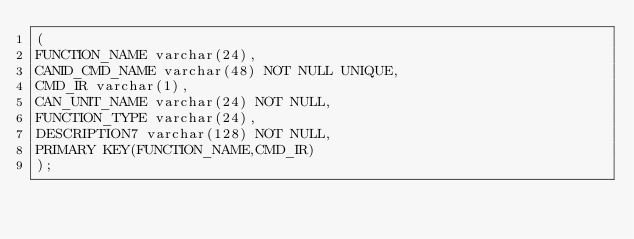Convert code to text. <code><loc_0><loc_0><loc_500><loc_500><_SQL_>(
FUNCTION_NAME varchar(24),
CANID_CMD_NAME varchar(48) NOT NULL UNIQUE,
CMD_IR varchar(1),
CAN_UNIT_NAME varchar(24) NOT NULL,
FUNCTION_TYPE varchar(24),
DESCRIPTION7 varchar(128) NOT NULL,
PRIMARY KEY(FUNCTION_NAME,CMD_IR)
);


</code> 